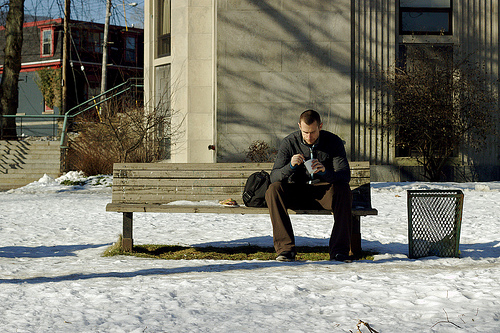<image>
Is the man on the bench? Yes. Looking at the image, I can see the man is positioned on top of the bench, with the bench providing support. Is the man on the cup? No. The man is not positioned on the cup. They may be near each other, but the man is not supported by or resting on top of the cup. 